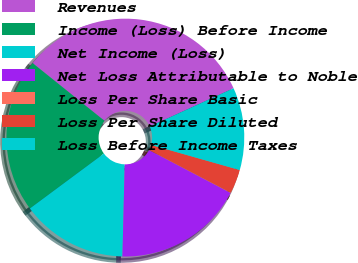<chart> <loc_0><loc_0><loc_500><loc_500><pie_chart><fcel>Revenues<fcel>Income (Loss) Before Income<fcel>Net Income (Loss)<fcel>Net Loss Attributable to Noble<fcel>Loss Per Share Basic<fcel>Loss Per Share Diluted<fcel>Loss Before Income Taxes<nl><fcel>32.42%<fcel>20.93%<fcel>14.45%<fcel>17.69%<fcel>0.03%<fcel>3.27%<fcel>11.21%<nl></chart> 